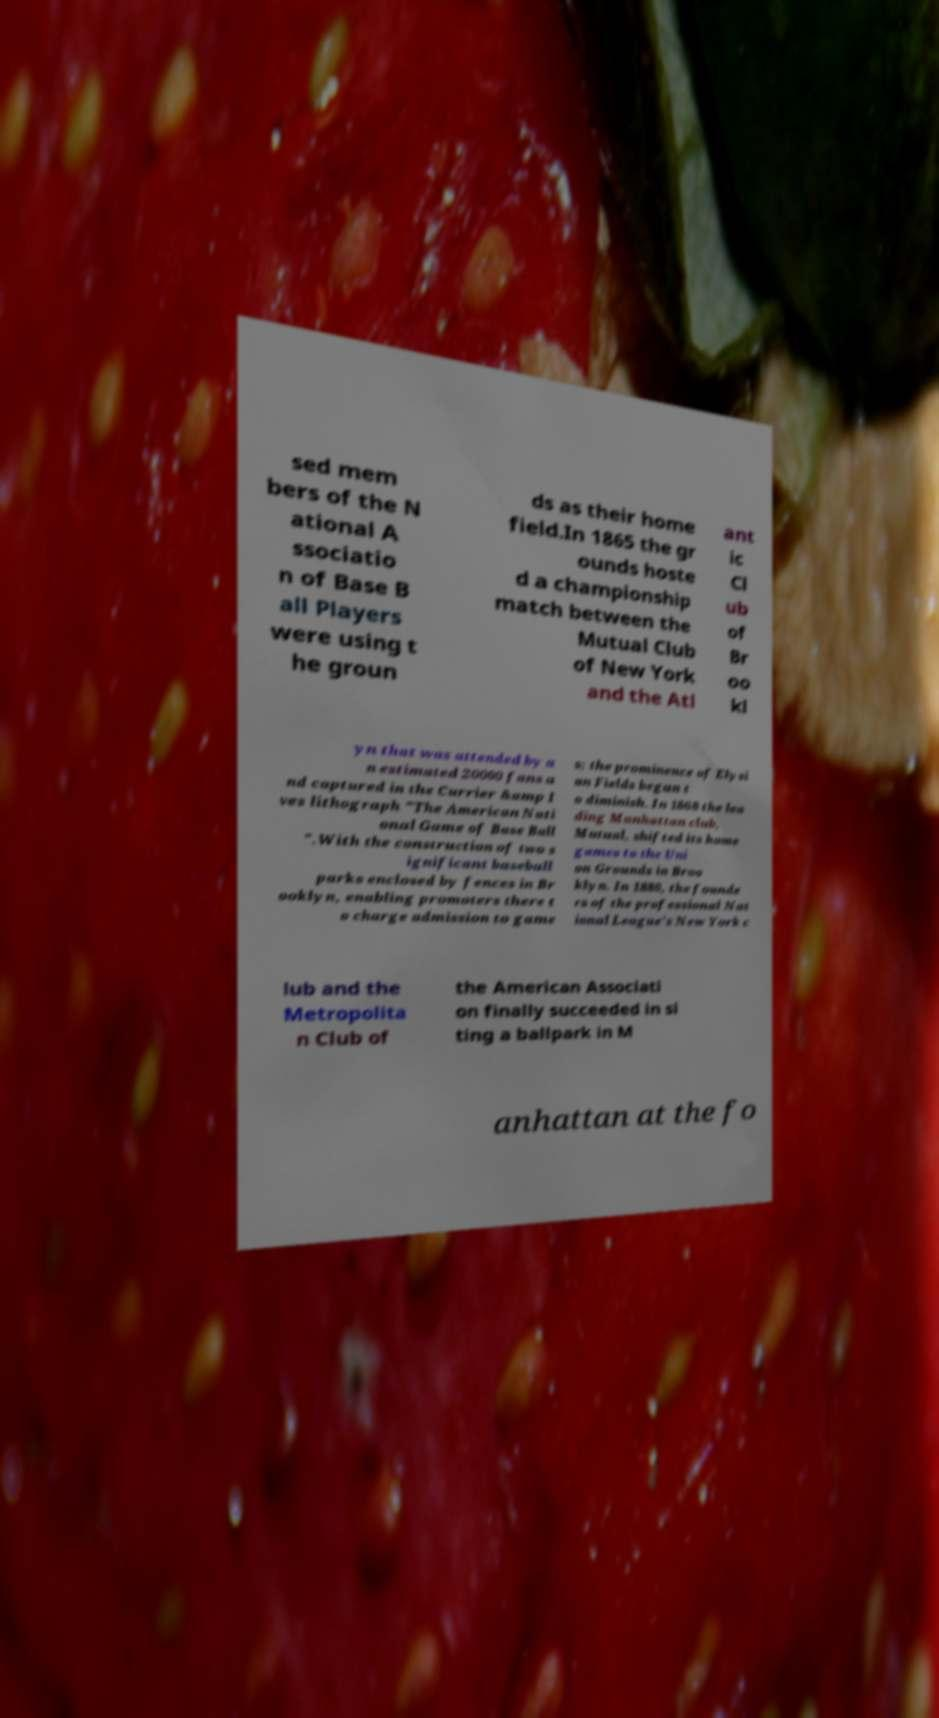Please read and relay the text visible in this image. What does it say? sed mem bers of the N ational A ssociatio n of Base B all Players were using t he groun ds as their home field.In 1865 the gr ounds hoste d a championship match between the Mutual Club of New York and the Atl ant ic Cl ub of Br oo kl yn that was attended by a n estimated 20000 fans a nd captured in the Currier &amp I ves lithograph "The American Nati onal Game of Base Ball ".With the construction of two s ignificant baseball parks enclosed by fences in Br ooklyn, enabling promoters there t o charge admission to game s; the prominence of Elysi an Fields began t o diminish. In 1868 the lea ding Manhattan club, Mutual, shifted its home games to the Uni on Grounds in Broo klyn. In 1880, the founde rs of the professional Nat ional League's New York c lub and the Metropolita n Club of the American Associati on finally succeeded in si ting a ballpark in M anhattan at the fo 